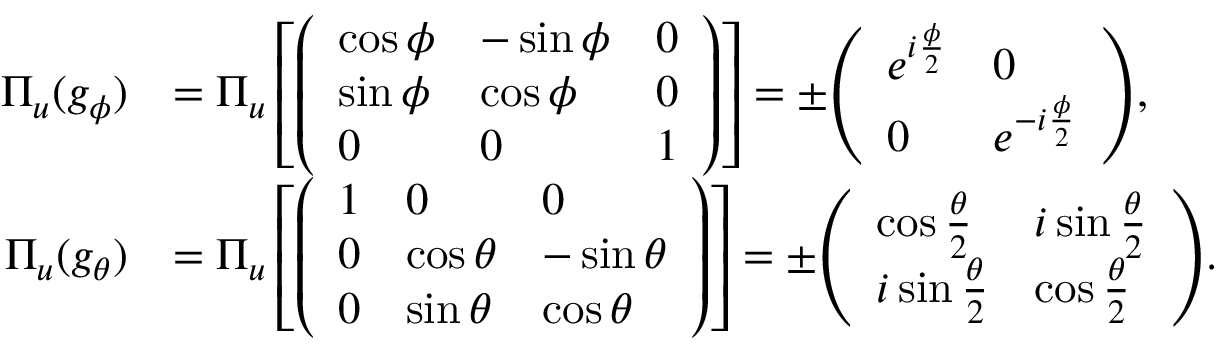Convert formula to latex. <formula><loc_0><loc_0><loc_500><loc_500>{ \begin{array} { r l } { \Pi _ { u } ( g _ { \phi } ) } & { = \Pi _ { u } \left [ { \left ( \begin{array} { l l l } { \cos \phi } & { - \sin \phi } & { 0 } \\ { \sin \phi } & { \cos \phi } & { 0 } \\ { 0 } & { 0 } & { 1 } \end{array} \right ) } \right ] = \pm { \left ( \begin{array} { l l } { e ^ { i { \frac { \phi } { 2 } } } } & { 0 } \\ { 0 } & { e ^ { - i { \frac { \phi } { 2 } } } } \end{array} \right ) } , } \\ { \Pi _ { u } ( g _ { \theta } ) } & { = \Pi _ { u } \left [ { \left ( \begin{array} { l l l } { 1 } & { 0 } & { 0 } \\ { 0 } & { \cos \theta } & { - \sin \theta } \\ { 0 } & { \sin \theta } & { \cos \theta } \end{array} \right ) } \right ] = \pm { \left ( \begin{array} { l l } { \cos { \frac { \theta } { 2 } } } & { i \sin { \frac { \theta } { 2 } } } \\ { i \sin { \frac { \theta } { 2 } } } & { \cos { \frac { \theta } { 2 } } } \end{array} \right ) } . } \end{array} }</formula> 